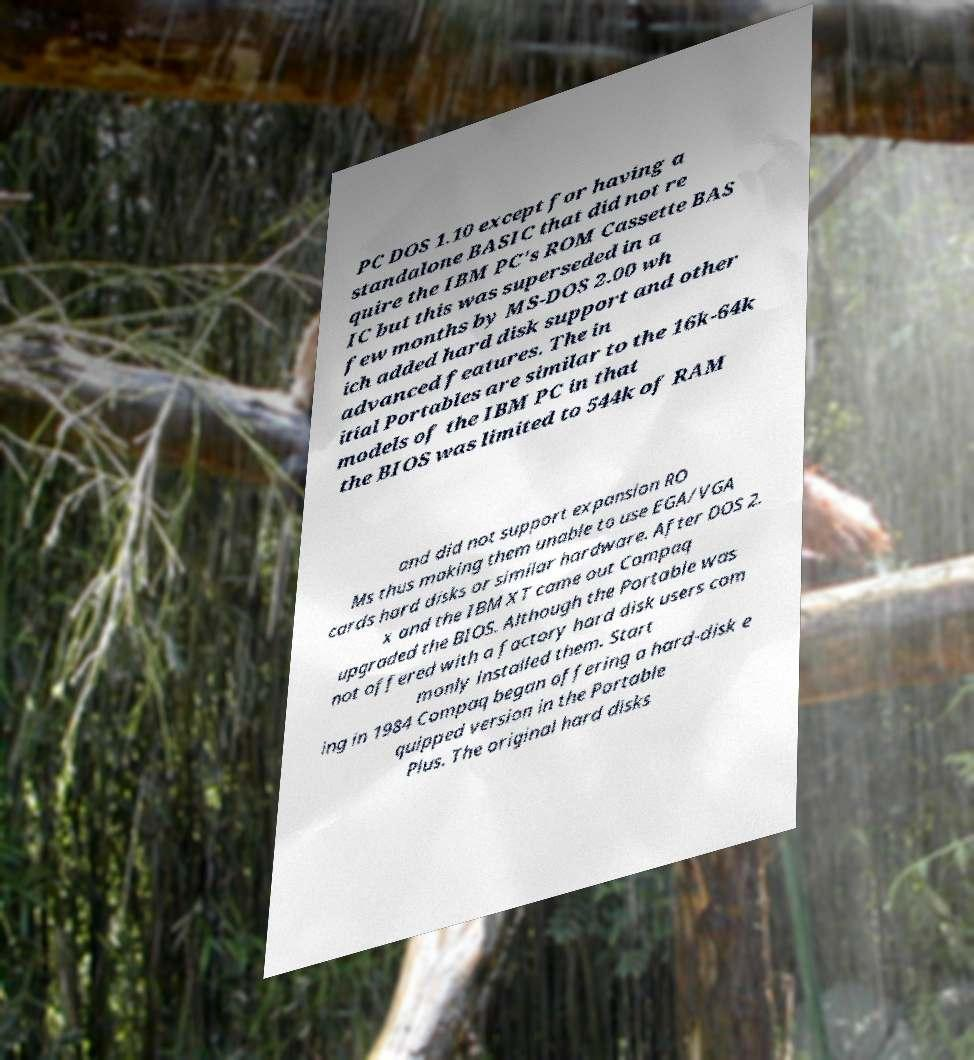Could you extract and type out the text from this image? PC DOS 1.10 except for having a standalone BASIC that did not re quire the IBM PC's ROM Cassette BAS IC but this was superseded in a few months by MS-DOS 2.00 wh ich added hard disk support and other advanced features. The in itial Portables are similar to the 16k-64k models of the IBM PC in that the BIOS was limited to 544k of RAM and did not support expansion RO Ms thus making them unable to use EGA/VGA cards hard disks or similar hardware. After DOS 2. x and the IBM XT came out Compaq upgraded the BIOS. Although the Portable was not offered with a factory hard disk users com monly installed them. Start ing in 1984 Compaq began offering a hard-disk e quipped version in the Portable Plus. The original hard disks 